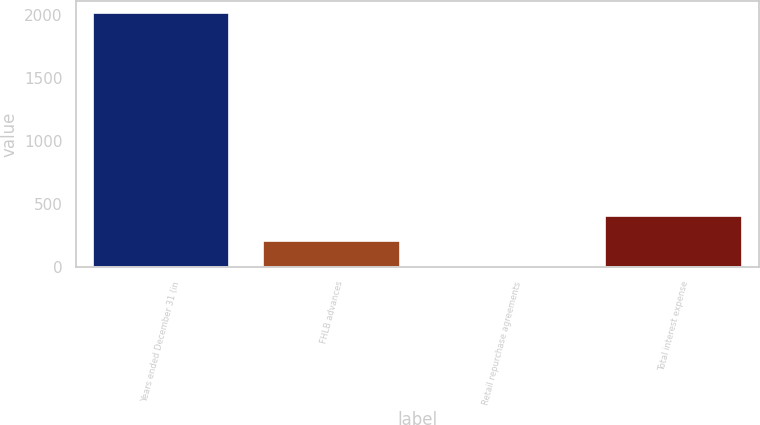Convert chart. <chart><loc_0><loc_0><loc_500><loc_500><bar_chart><fcel>Years ended December 31 (in<fcel>FHLB advances<fcel>Retail repurchase agreements<fcel>Total interest expense<nl><fcel>2011<fcel>202.9<fcel>2<fcel>403.8<nl></chart> 